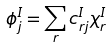Convert formula to latex. <formula><loc_0><loc_0><loc_500><loc_500>\phi _ { j } ^ { I } = \sum _ { r } c _ { r j } ^ { I } \chi _ { r } ^ { I }</formula> 